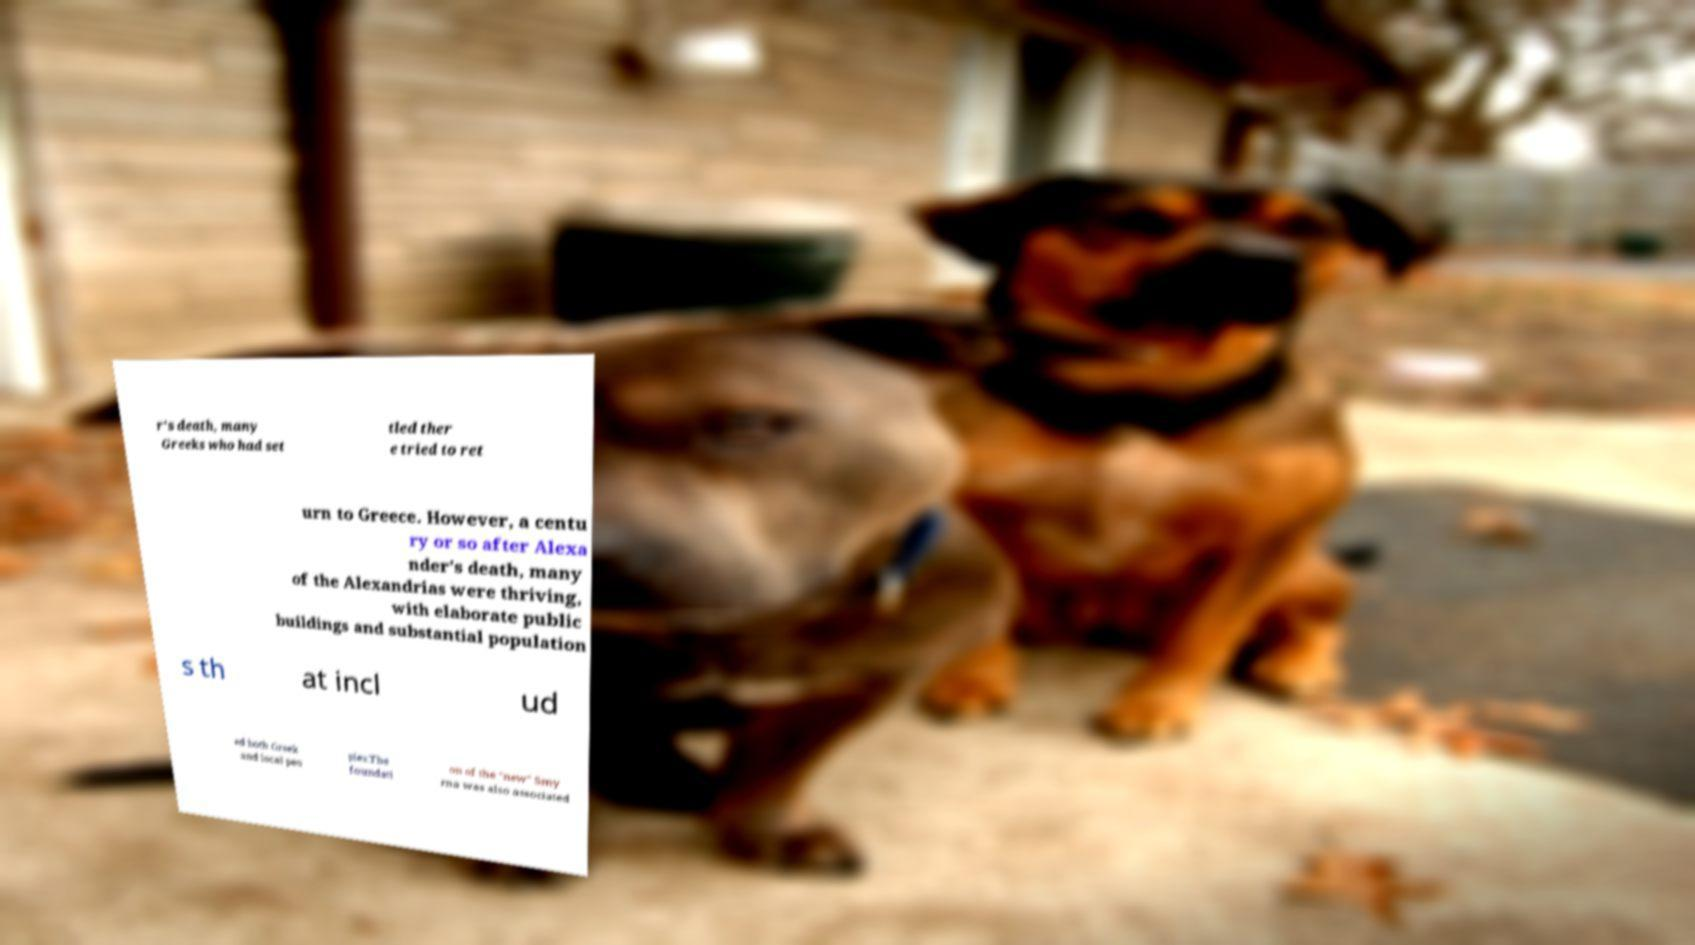Please identify and transcribe the text found in this image. r's death, many Greeks who had set tled ther e tried to ret urn to Greece. However, a centu ry or so after Alexa nder's death, many of the Alexandrias were thriving, with elaborate public buildings and substantial population s th at incl ud ed both Greek and local peo ples.The foundati on of the "new" Smy rna was also associated 